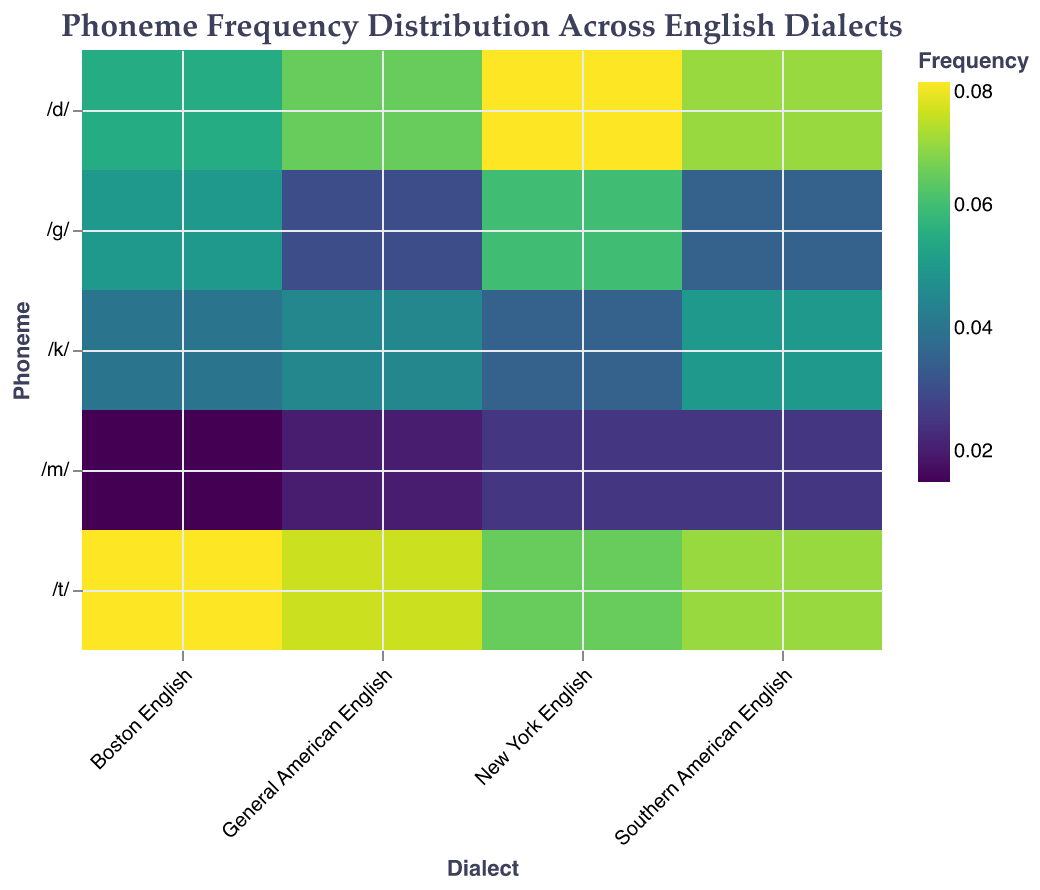What is the title of the heatmap? Look at the top of the heatmap where the title is located. The title describes the topic of the figure.
Answer: Phoneme Frequency Distribution Across English Dialects Which dialect has the highest frequency for the phoneme /t/? Observe the cells corresponding to the phoneme /t/ across different dialects. Compare the color shade or value.
Answer: Boston English What is the frequency of the phoneme /m/ in Southern American English? Find the cell located at the intersection of the /m/ row and Southern American English column. Use the tooltip or color shade to determine the frequency.
Answer: 0.025 Which phoneme has the highest frequency in General American English? Observe the cells in the General American English column and identify the darkest or most intense color, corresponding to the highest frequency.
Answer: /t/ How do the frequencies of the phoneme /g/ compare across the different dialects? Examine the cells for the phoneme /g/ across all dialects and compare the values or color intensities.
Answer: Highest in New York English (0.060), followed by Boston English (0.050), Southern American English (0.035), and General American English (0.030) What's the difference in frequency of the phoneme /d/ between New York English and Boston English? Subtract the frequency value of /d/ in Boston English from the frequency value of /d/ in New York English.
Answer: 0.080 - 0.055 = 0.025 Which dialect has the lowest overall frequency of the phoneme /m/? Examine the cells corresponding to the phoneme /m/ across all dialects and identify the cell with the lowest value or lightest color shade.
Answer: Boston English Rank the dialects in descending order based on the frequency of the phoneme /k/. Compare the frequency values of /k/ across all dialects and arrange them from highest to lowest.
Answer: Southern American English (0.050), General American English (0.045), Boston English (0.040), New York English (0.035) What is the average frequency of the phoneme /d/ across all dialects? Sum the frequency values of /d/ for all dialects and divide by the number of dialects (4 in this case).
Answer: (0.065 + 0.070 + 0.055 + 0.080) / 4 = 0.0675 